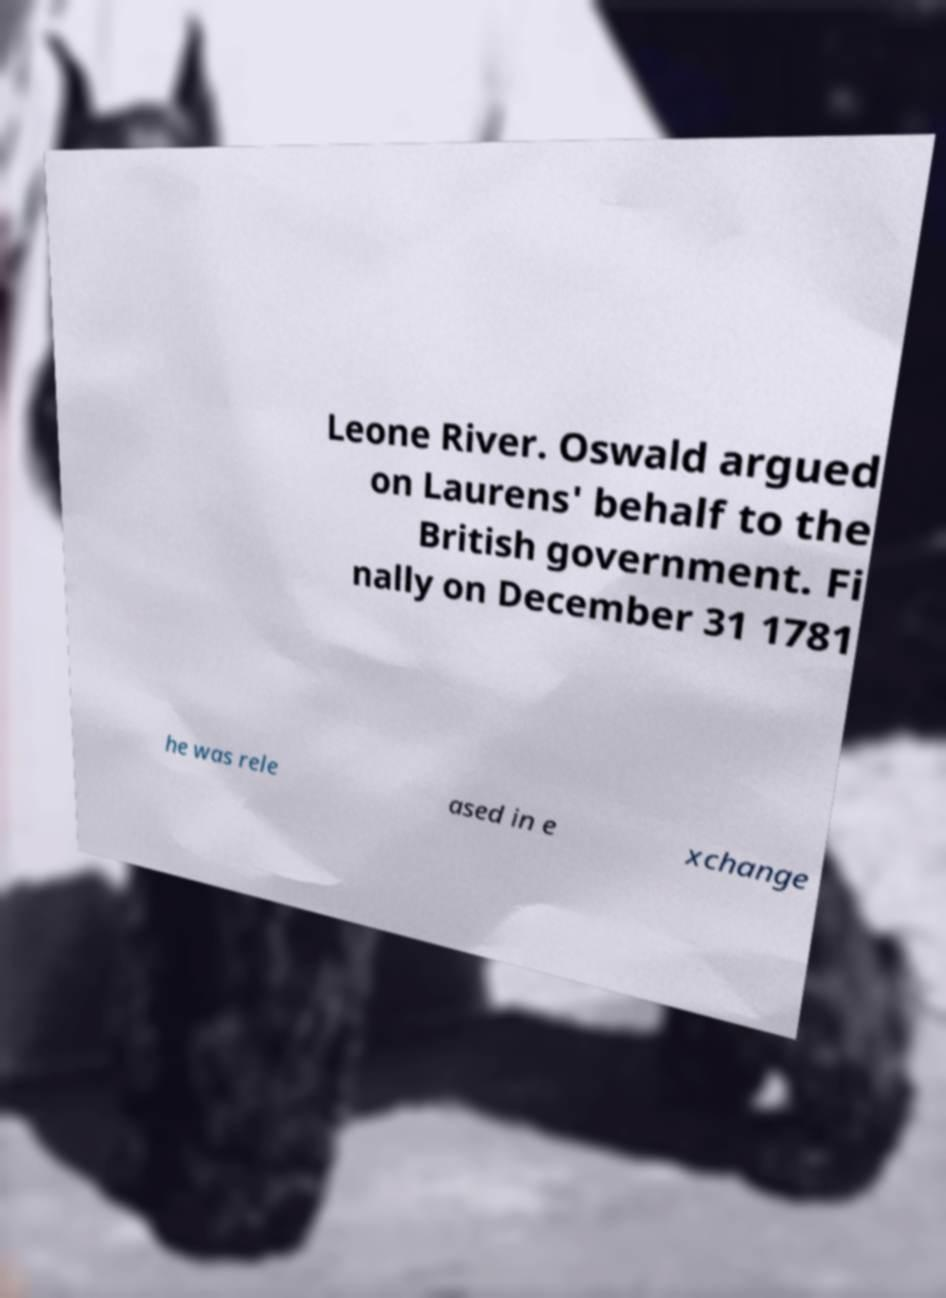Please read and relay the text visible in this image. What does it say? Leone River. Oswald argued on Laurens' behalf to the British government. Fi nally on December 31 1781 he was rele ased in e xchange 